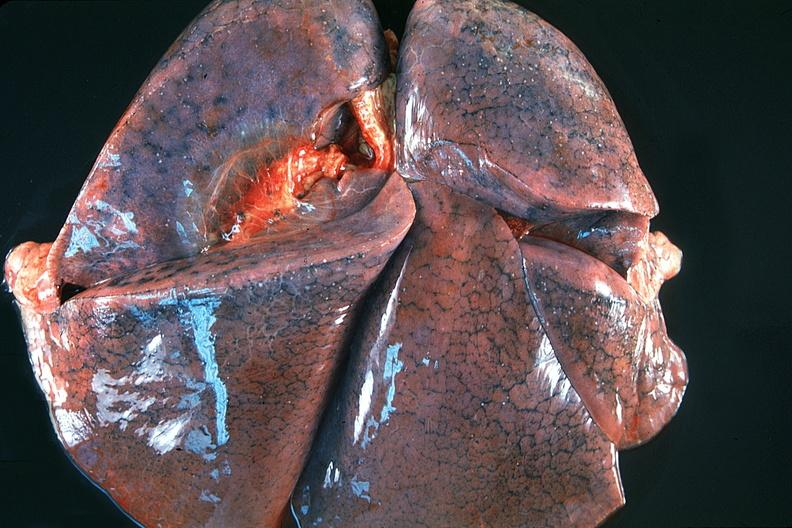s respiratory present?
Answer the question using a single word or phrase. Yes 